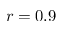Convert formula to latex. <formula><loc_0><loc_0><loc_500><loc_500>r = 0 . 9</formula> 